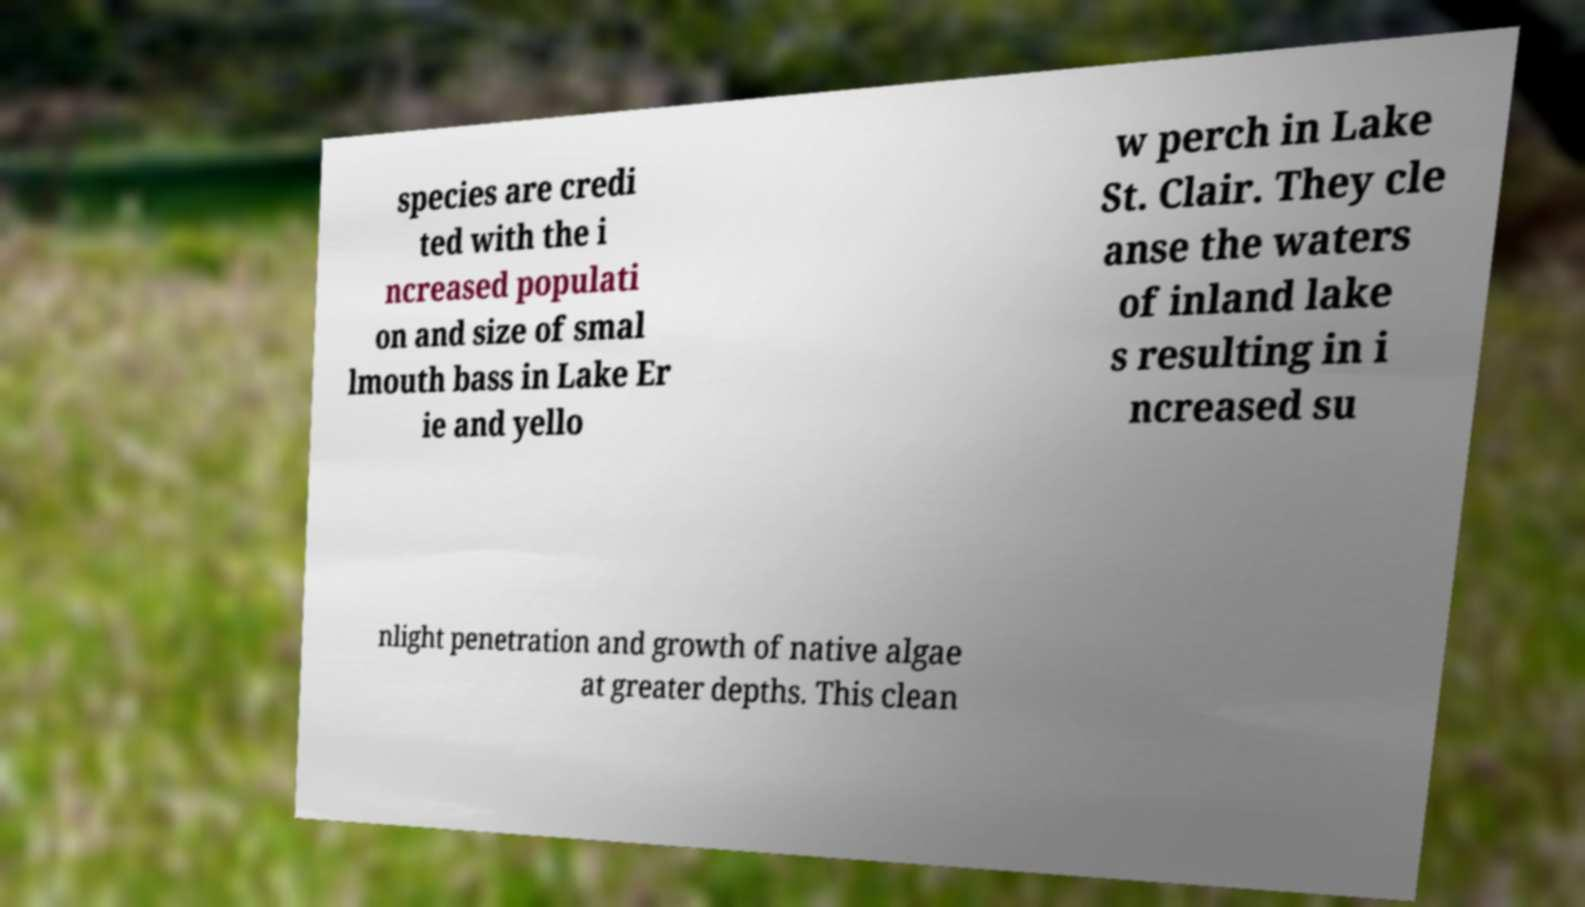Can you accurately transcribe the text from the provided image for me? species are credi ted with the i ncreased populati on and size of smal lmouth bass in Lake Er ie and yello w perch in Lake St. Clair. They cle anse the waters of inland lake s resulting in i ncreased su nlight penetration and growth of native algae at greater depths. This clean 